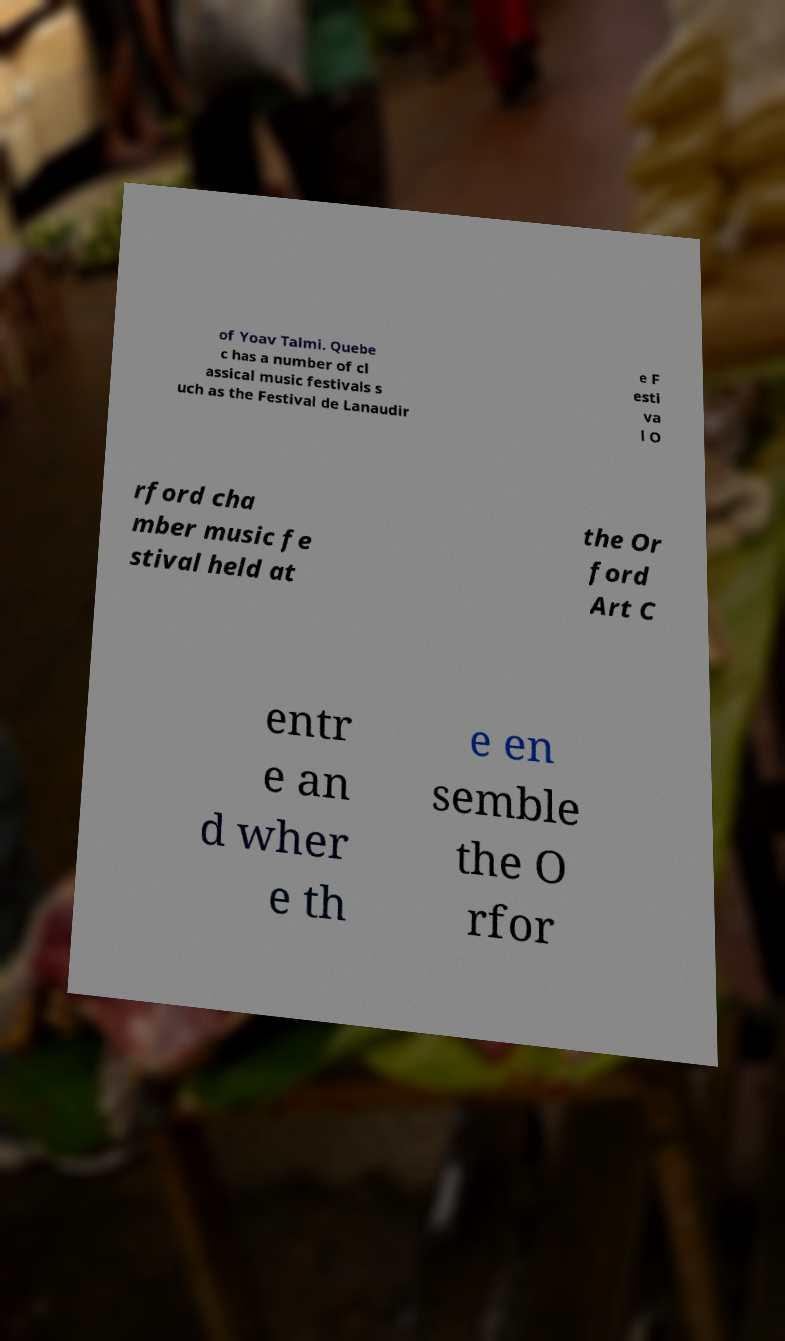Could you assist in decoding the text presented in this image and type it out clearly? of Yoav Talmi. Quebe c has a number of cl assical music festivals s uch as the Festival de Lanaudir e F esti va l O rford cha mber music fe stival held at the Or ford Art C entr e an d wher e th e en semble the O rfor 